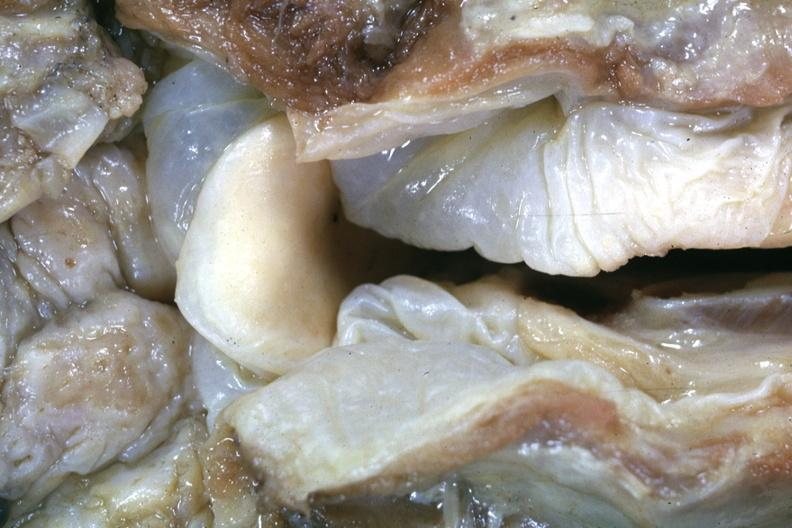when does this image show close-up view of very edematous hypopharyngeal mucosa with opened larynx this is a very good example of a lesion seldom seen at autopsy slide is a more distant view of this specimen?
Answer the question using a single word or phrase. After fixation 